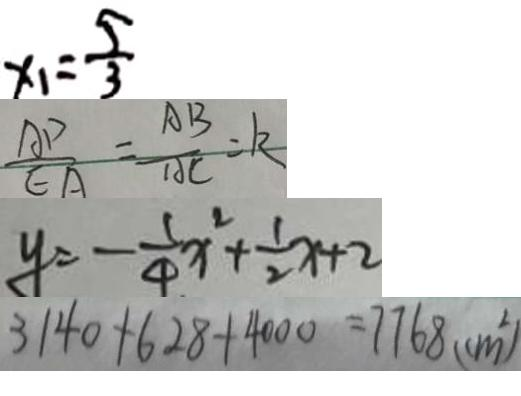<formula> <loc_0><loc_0><loc_500><loc_500>x _ { 1 } = \frac { 5 } { 3 } 
 \frac { A P } { E A } = \frac { A B } { A C } = k 
 y = - \frac { 1 } { 4 } x ^ { 2 } + \frac { 1 } { 2 } x + 2 
 3 1 4 0 + 6 2 8 + 4 0 0 0 = 7 7 6 8 ( c m ^ { 2 } )</formula> 